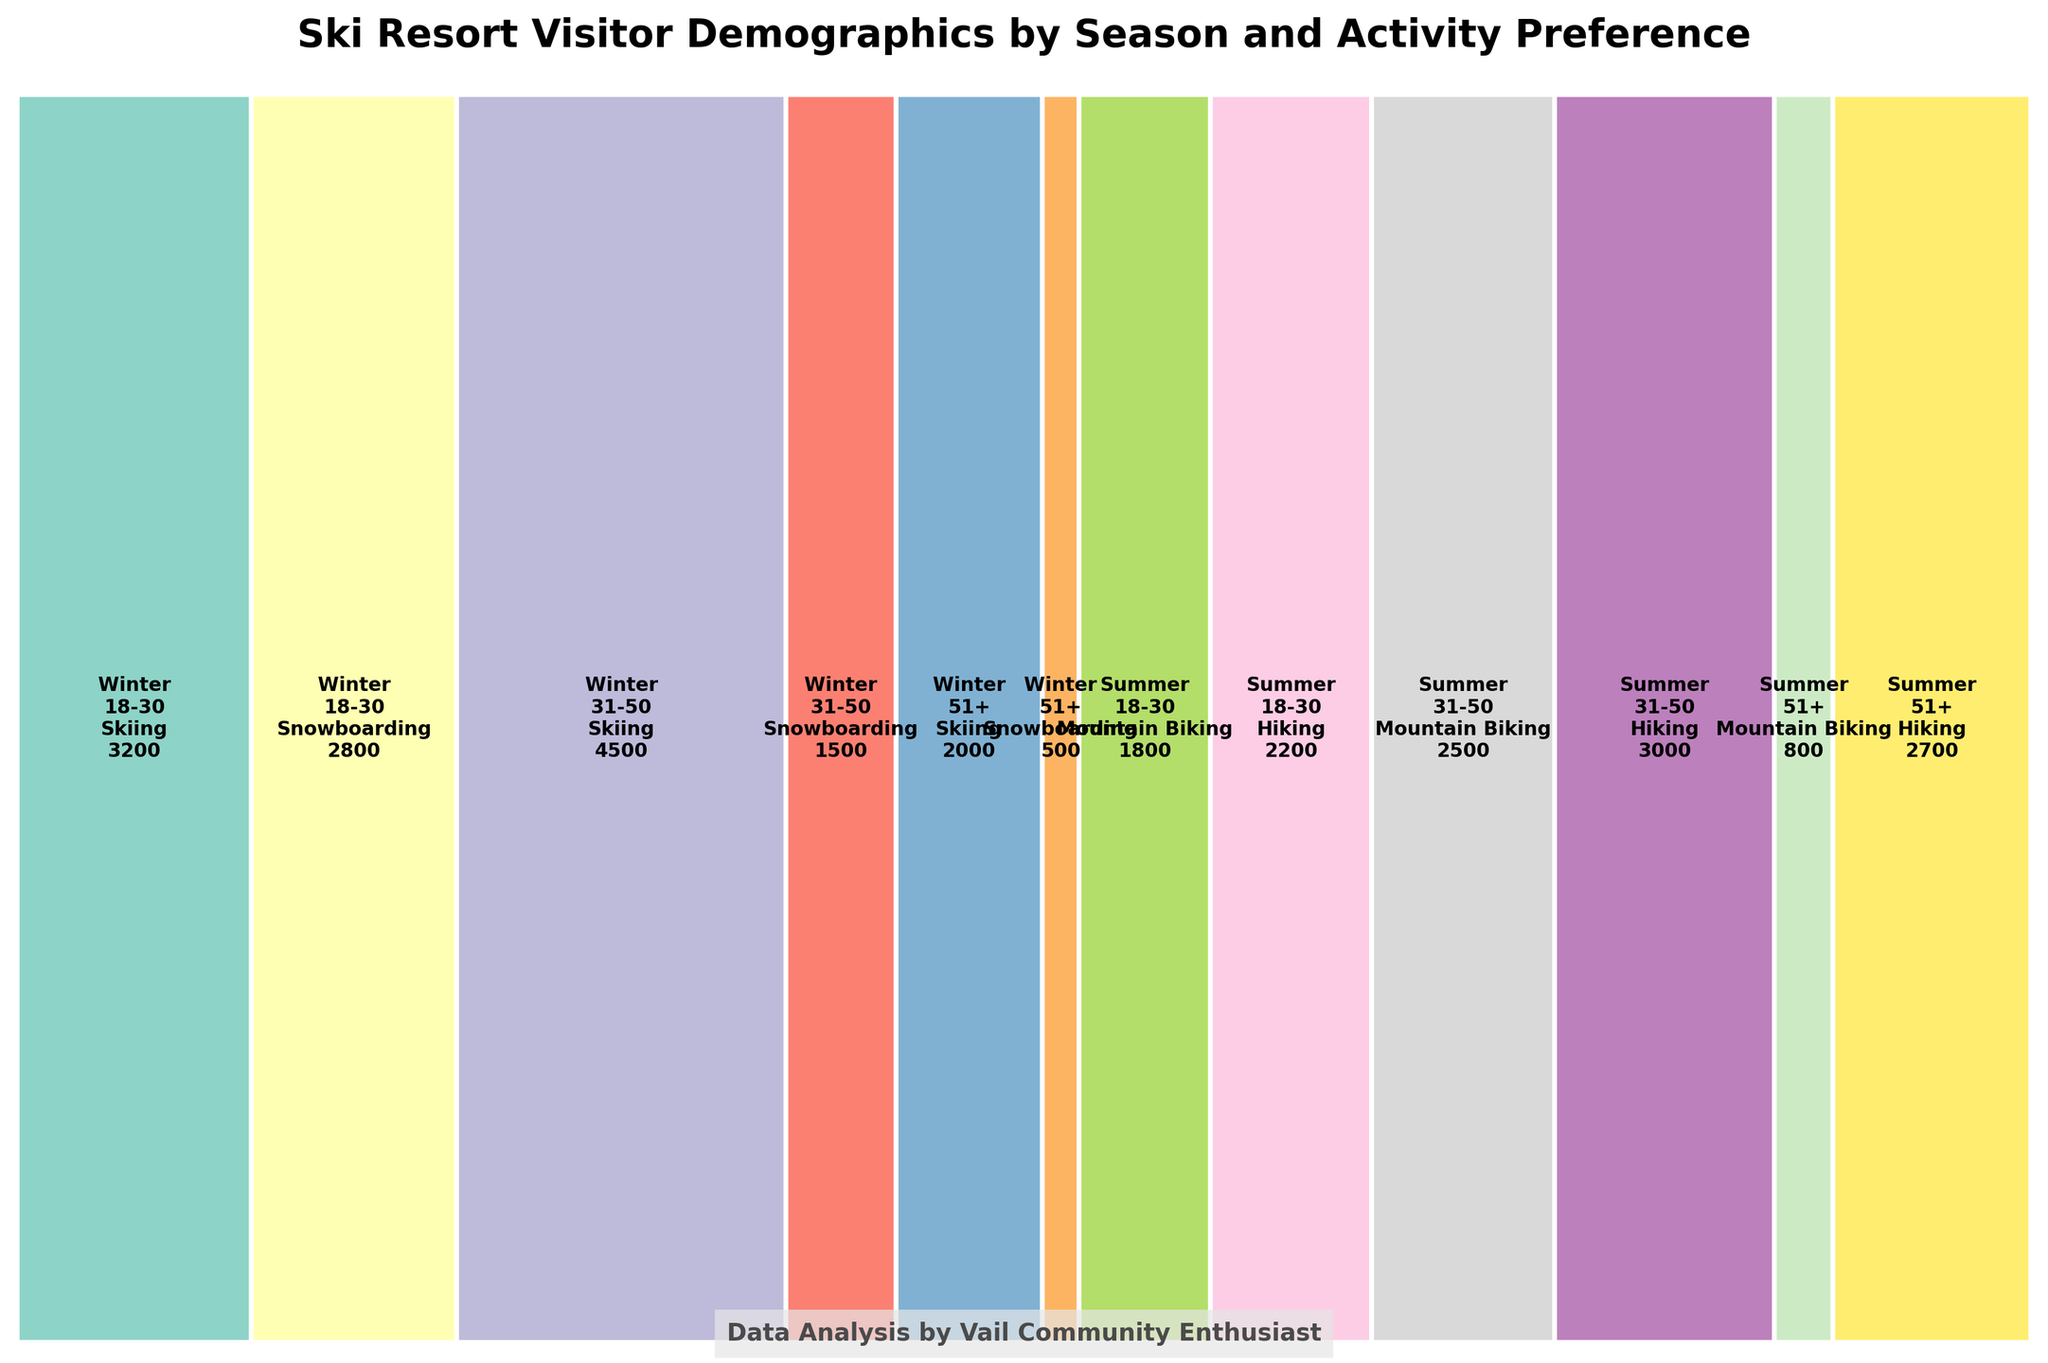What is the title of the figure? The title of the figure is stated at the top of the plot. It summarizes the overall content.
Answer: Ski Resort Visitor Demographics by Season and Activity Preference Which age group has the least number of visitors for Snowboarding in Winter? By looking at the rectangles labeled as Snowboarding in Winter and comparing the visitor numbers, we can identify which age group has the least.
Answer: 51+ Which season has the most Mountain Biking visitors in the 31-50 age group? We observe the sections labeled as Mountain Biking and see which season has more visitors for the 31-50 age group.
Answer: Summer What's the total number of visitors for Hiking in Summer across all age groups? Sum the visitor numbers for Hiking in Summer from all age groups.
Answer: 2200 + 3000 + 2700 = 7900 Do more people aged 18-30 prefer Skiing or Snowboarding in Winter? Compare the number of visitors in Winter for the 18-30 age group between Skiing and Snowboarding.
Answer: Skiing Which activity has the largest proportion of visitors in Winter across all age groups? Add up the visitors for each activity in Winter and compare the totals.
Answer: Skiing How does the proportion of 51+ visitors for Hiking in Summer compare to Mountain Biking in the same age group? Check the proportion of visitors for Hiking and Mountain Biking in Summer for the 51+ age group by looking at the respective rectangles.
Answer: Hiking is higher Which season and activity combination has the least number of visitors? Identify the rectangle with the smallest visitor number across all seasons and activities.
Answer: Snowboarding in Winter (51+ age group) What is the combined proportion of visitors for both Mountain Biking and Hiking in Summer? Sum the proportions of visitors for Mountain Biking and Hiking in Summer across all age groups.
Answer: Total proportion for Mountain Biking and Hiking in Summer What's the total number of visitors for the 31-50 age group across all seasons and activities? Sum the visitor numbers for the 31-50 age group in both Winter and Summer across all activities.
Answer: 4500 + 1500 + 2500 + 3000 = 11500 